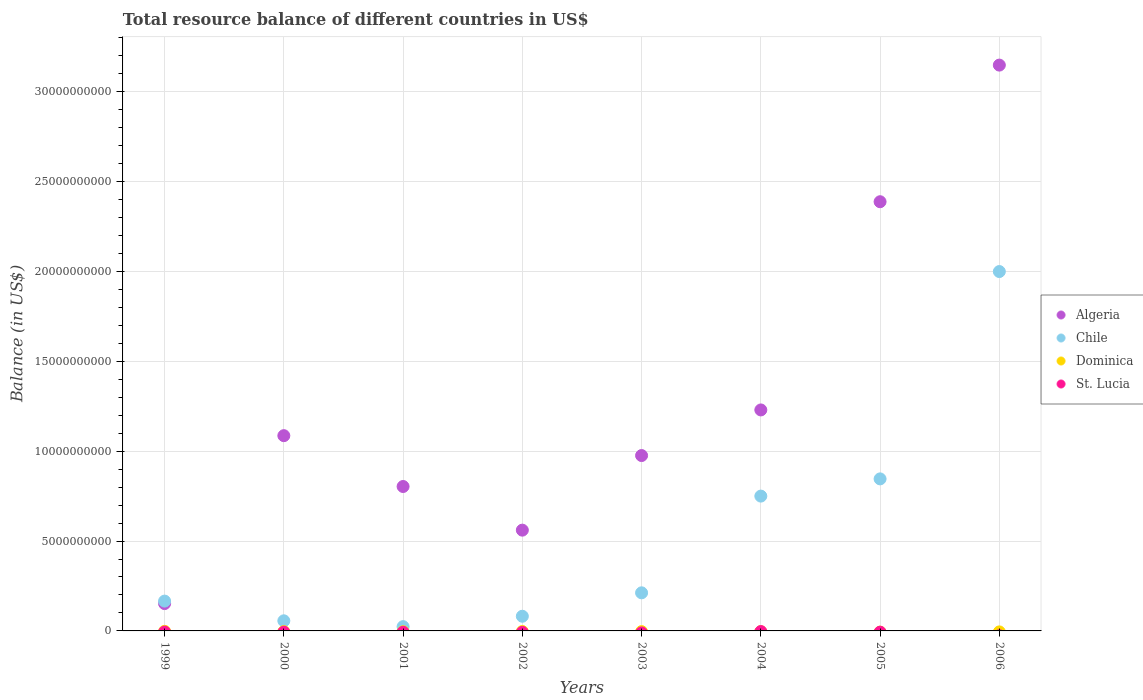What is the total resource balance in Algeria in 2003?
Provide a succinct answer. 9.75e+09. Across all years, what is the maximum total resource balance in Algeria?
Your answer should be compact. 3.15e+1. Across all years, what is the minimum total resource balance in Algeria?
Provide a succinct answer. 1.52e+09. In which year was the total resource balance in Chile maximum?
Make the answer very short. 2006. What is the total total resource balance in St. Lucia in the graph?
Ensure brevity in your answer.  0. What is the difference between the total resource balance in Algeria in 1999 and that in 2002?
Offer a very short reply. -4.09e+09. What is the difference between the total resource balance in Dominica in 2002 and the total resource balance in Algeria in 2003?
Ensure brevity in your answer.  -9.75e+09. What is the average total resource balance in Chile per year?
Ensure brevity in your answer.  5.17e+09. In the year 2006, what is the difference between the total resource balance in Chile and total resource balance in Algeria?
Your response must be concise. -1.15e+1. What is the ratio of the total resource balance in Chile in 1999 to that in 2001?
Offer a terse response. 6.95. What is the difference between the highest and the second highest total resource balance in Algeria?
Keep it short and to the point. 7.60e+09. What is the difference between the highest and the lowest total resource balance in Algeria?
Make the answer very short. 3.00e+1. In how many years, is the total resource balance in Dominica greater than the average total resource balance in Dominica taken over all years?
Your answer should be very brief. 0. Is the sum of the total resource balance in Chile in 2002 and 2006 greater than the maximum total resource balance in St. Lucia across all years?
Your answer should be compact. Yes. Is the total resource balance in St. Lucia strictly less than the total resource balance in Chile over the years?
Make the answer very short. Yes. How many years are there in the graph?
Provide a short and direct response. 8. Are the values on the major ticks of Y-axis written in scientific E-notation?
Keep it short and to the point. No. How many legend labels are there?
Make the answer very short. 4. What is the title of the graph?
Provide a succinct answer. Total resource balance of different countries in US$. What is the label or title of the Y-axis?
Ensure brevity in your answer.  Balance (in US$). What is the Balance (in US$) of Algeria in 1999?
Your answer should be very brief. 1.52e+09. What is the Balance (in US$) in Chile in 1999?
Provide a short and direct response. 1.66e+09. What is the Balance (in US$) in St. Lucia in 1999?
Make the answer very short. 0. What is the Balance (in US$) in Algeria in 2000?
Ensure brevity in your answer.  1.09e+1. What is the Balance (in US$) in Chile in 2000?
Offer a very short reply. 5.63e+08. What is the Balance (in US$) of Dominica in 2000?
Your answer should be compact. 0. What is the Balance (in US$) of St. Lucia in 2000?
Keep it short and to the point. 0. What is the Balance (in US$) of Algeria in 2001?
Offer a very short reply. 8.03e+09. What is the Balance (in US$) of Chile in 2001?
Offer a very short reply. 2.38e+08. What is the Balance (in US$) of Dominica in 2001?
Your answer should be very brief. 0. What is the Balance (in US$) in Algeria in 2002?
Keep it short and to the point. 5.61e+09. What is the Balance (in US$) of Chile in 2002?
Keep it short and to the point. 8.16e+08. What is the Balance (in US$) in Dominica in 2002?
Offer a terse response. 0. What is the Balance (in US$) in St. Lucia in 2002?
Make the answer very short. 0. What is the Balance (in US$) of Algeria in 2003?
Offer a very short reply. 9.75e+09. What is the Balance (in US$) of Chile in 2003?
Give a very brief answer. 2.12e+09. What is the Balance (in US$) in Algeria in 2004?
Offer a terse response. 1.23e+1. What is the Balance (in US$) of Chile in 2004?
Your response must be concise. 7.50e+09. What is the Balance (in US$) in St. Lucia in 2004?
Give a very brief answer. 0. What is the Balance (in US$) of Algeria in 2005?
Your answer should be very brief. 2.39e+1. What is the Balance (in US$) in Chile in 2005?
Offer a very short reply. 8.46e+09. What is the Balance (in US$) in Dominica in 2005?
Provide a succinct answer. 0. What is the Balance (in US$) of Algeria in 2006?
Your answer should be very brief. 3.15e+1. What is the Balance (in US$) of Chile in 2006?
Offer a terse response. 2.00e+1. What is the Balance (in US$) of St. Lucia in 2006?
Offer a very short reply. 0. Across all years, what is the maximum Balance (in US$) of Algeria?
Keep it short and to the point. 3.15e+1. Across all years, what is the maximum Balance (in US$) of Chile?
Keep it short and to the point. 2.00e+1. Across all years, what is the minimum Balance (in US$) in Algeria?
Offer a very short reply. 1.52e+09. Across all years, what is the minimum Balance (in US$) of Chile?
Make the answer very short. 2.38e+08. What is the total Balance (in US$) in Algeria in the graph?
Make the answer very short. 1.03e+11. What is the total Balance (in US$) of Chile in the graph?
Offer a very short reply. 4.13e+1. What is the difference between the Balance (in US$) in Algeria in 1999 and that in 2000?
Offer a terse response. -9.34e+09. What is the difference between the Balance (in US$) in Chile in 1999 and that in 2000?
Offer a very short reply. 1.10e+09. What is the difference between the Balance (in US$) of Algeria in 1999 and that in 2001?
Provide a short and direct response. -6.51e+09. What is the difference between the Balance (in US$) in Chile in 1999 and that in 2001?
Provide a succinct answer. 1.42e+09. What is the difference between the Balance (in US$) in Algeria in 1999 and that in 2002?
Give a very brief answer. -4.09e+09. What is the difference between the Balance (in US$) in Chile in 1999 and that in 2002?
Offer a very short reply. 8.43e+08. What is the difference between the Balance (in US$) of Algeria in 1999 and that in 2003?
Your answer should be compact. -8.23e+09. What is the difference between the Balance (in US$) in Chile in 1999 and that in 2003?
Ensure brevity in your answer.  -4.60e+08. What is the difference between the Balance (in US$) in Algeria in 1999 and that in 2004?
Keep it short and to the point. -1.08e+1. What is the difference between the Balance (in US$) of Chile in 1999 and that in 2004?
Your answer should be compact. -5.84e+09. What is the difference between the Balance (in US$) in Algeria in 1999 and that in 2005?
Keep it short and to the point. -2.24e+1. What is the difference between the Balance (in US$) in Chile in 1999 and that in 2005?
Ensure brevity in your answer.  -6.80e+09. What is the difference between the Balance (in US$) of Algeria in 1999 and that in 2006?
Offer a terse response. -3.00e+1. What is the difference between the Balance (in US$) in Chile in 1999 and that in 2006?
Provide a short and direct response. -1.83e+1. What is the difference between the Balance (in US$) in Algeria in 2000 and that in 2001?
Make the answer very short. 2.83e+09. What is the difference between the Balance (in US$) in Chile in 2000 and that in 2001?
Provide a short and direct response. 3.24e+08. What is the difference between the Balance (in US$) of Algeria in 2000 and that in 2002?
Give a very brief answer. 5.25e+09. What is the difference between the Balance (in US$) of Chile in 2000 and that in 2002?
Your answer should be very brief. -2.53e+08. What is the difference between the Balance (in US$) in Algeria in 2000 and that in 2003?
Provide a succinct answer. 1.11e+09. What is the difference between the Balance (in US$) in Chile in 2000 and that in 2003?
Your answer should be compact. -1.56e+09. What is the difference between the Balance (in US$) of Algeria in 2000 and that in 2004?
Your answer should be compact. -1.43e+09. What is the difference between the Balance (in US$) in Chile in 2000 and that in 2004?
Your answer should be compact. -6.94e+09. What is the difference between the Balance (in US$) in Algeria in 2000 and that in 2005?
Provide a succinct answer. -1.30e+1. What is the difference between the Balance (in US$) of Chile in 2000 and that in 2005?
Your response must be concise. -7.89e+09. What is the difference between the Balance (in US$) of Algeria in 2000 and that in 2006?
Your response must be concise. -2.06e+1. What is the difference between the Balance (in US$) of Chile in 2000 and that in 2006?
Make the answer very short. -1.94e+1. What is the difference between the Balance (in US$) in Algeria in 2001 and that in 2002?
Provide a short and direct response. 2.43e+09. What is the difference between the Balance (in US$) of Chile in 2001 and that in 2002?
Keep it short and to the point. -5.78e+08. What is the difference between the Balance (in US$) in Algeria in 2001 and that in 2003?
Provide a short and direct response. -1.72e+09. What is the difference between the Balance (in US$) in Chile in 2001 and that in 2003?
Ensure brevity in your answer.  -1.88e+09. What is the difference between the Balance (in US$) in Algeria in 2001 and that in 2004?
Your answer should be compact. -4.26e+09. What is the difference between the Balance (in US$) of Chile in 2001 and that in 2004?
Ensure brevity in your answer.  -7.26e+09. What is the difference between the Balance (in US$) in Algeria in 2001 and that in 2005?
Make the answer very short. -1.58e+1. What is the difference between the Balance (in US$) of Chile in 2001 and that in 2005?
Your answer should be compact. -8.22e+09. What is the difference between the Balance (in US$) in Algeria in 2001 and that in 2006?
Offer a terse response. -2.34e+1. What is the difference between the Balance (in US$) of Chile in 2001 and that in 2006?
Your answer should be very brief. -1.97e+1. What is the difference between the Balance (in US$) in Algeria in 2002 and that in 2003?
Ensure brevity in your answer.  -4.15e+09. What is the difference between the Balance (in US$) in Chile in 2002 and that in 2003?
Your answer should be very brief. -1.30e+09. What is the difference between the Balance (in US$) in Algeria in 2002 and that in 2004?
Your answer should be compact. -6.69e+09. What is the difference between the Balance (in US$) in Chile in 2002 and that in 2004?
Your answer should be compact. -6.68e+09. What is the difference between the Balance (in US$) of Algeria in 2002 and that in 2005?
Ensure brevity in your answer.  -1.83e+1. What is the difference between the Balance (in US$) in Chile in 2002 and that in 2005?
Ensure brevity in your answer.  -7.64e+09. What is the difference between the Balance (in US$) in Algeria in 2002 and that in 2006?
Offer a terse response. -2.59e+1. What is the difference between the Balance (in US$) in Chile in 2002 and that in 2006?
Make the answer very short. -1.92e+1. What is the difference between the Balance (in US$) of Algeria in 2003 and that in 2004?
Offer a terse response. -2.54e+09. What is the difference between the Balance (in US$) of Chile in 2003 and that in 2004?
Your answer should be compact. -5.38e+09. What is the difference between the Balance (in US$) of Algeria in 2003 and that in 2005?
Offer a terse response. -1.41e+1. What is the difference between the Balance (in US$) of Chile in 2003 and that in 2005?
Offer a terse response. -6.34e+09. What is the difference between the Balance (in US$) in Algeria in 2003 and that in 2006?
Make the answer very short. -2.17e+1. What is the difference between the Balance (in US$) of Chile in 2003 and that in 2006?
Provide a short and direct response. -1.79e+1. What is the difference between the Balance (in US$) in Algeria in 2004 and that in 2005?
Your response must be concise. -1.16e+1. What is the difference between the Balance (in US$) in Chile in 2004 and that in 2005?
Give a very brief answer. -9.58e+08. What is the difference between the Balance (in US$) in Algeria in 2004 and that in 2006?
Make the answer very short. -1.92e+1. What is the difference between the Balance (in US$) of Chile in 2004 and that in 2006?
Keep it short and to the point. -1.25e+1. What is the difference between the Balance (in US$) in Algeria in 2005 and that in 2006?
Your response must be concise. -7.60e+09. What is the difference between the Balance (in US$) of Chile in 2005 and that in 2006?
Provide a succinct answer. -1.15e+1. What is the difference between the Balance (in US$) in Algeria in 1999 and the Balance (in US$) in Chile in 2000?
Give a very brief answer. 9.57e+08. What is the difference between the Balance (in US$) in Algeria in 1999 and the Balance (in US$) in Chile in 2001?
Offer a very short reply. 1.28e+09. What is the difference between the Balance (in US$) of Algeria in 1999 and the Balance (in US$) of Chile in 2002?
Your answer should be very brief. 7.04e+08. What is the difference between the Balance (in US$) in Algeria in 1999 and the Balance (in US$) in Chile in 2003?
Give a very brief answer. -5.99e+08. What is the difference between the Balance (in US$) in Algeria in 1999 and the Balance (in US$) in Chile in 2004?
Your answer should be very brief. -5.98e+09. What is the difference between the Balance (in US$) of Algeria in 1999 and the Balance (in US$) of Chile in 2005?
Offer a very short reply. -6.94e+09. What is the difference between the Balance (in US$) in Algeria in 1999 and the Balance (in US$) in Chile in 2006?
Provide a short and direct response. -1.85e+1. What is the difference between the Balance (in US$) of Algeria in 2000 and the Balance (in US$) of Chile in 2001?
Make the answer very short. 1.06e+1. What is the difference between the Balance (in US$) in Algeria in 2000 and the Balance (in US$) in Chile in 2002?
Offer a very short reply. 1.00e+1. What is the difference between the Balance (in US$) in Algeria in 2000 and the Balance (in US$) in Chile in 2003?
Ensure brevity in your answer.  8.74e+09. What is the difference between the Balance (in US$) of Algeria in 2000 and the Balance (in US$) of Chile in 2004?
Make the answer very short. 3.36e+09. What is the difference between the Balance (in US$) in Algeria in 2000 and the Balance (in US$) in Chile in 2005?
Make the answer very short. 2.40e+09. What is the difference between the Balance (in US$) in Algeria in 2000 and the Balance (in US$) in Chile in 2006?
Keep it short and to the point. -9.13e+09. What is the difference between the Balance (in US$) of Algeria in 2001 and the Balance (in US$) of Chile in 2002?
Provide a short and direct response. 7.22e+09. What is the difference between the Balance (in US$) in Algeria in 2001 and the Balance (in US$) in Chile in 2003?
Provide a succinct answer. 5.91e+09. What is the difference between the Balance (in US$) in Algeria in 2001 and the Balance (in US$) in Chile in 2004?
Offer a very short reply. 5.34e+08. What is the difference between the Balance (in US$) in Algeria in 2001 and the Balance (in US$) in Chile in 2005?
Keep it short and to the point. -4.24e+08. What is the difference between the Balance (in US$) of Algeria in 2001 and the Balance (in US$) of Chile in 2006?
Provide a short and direct response. -1.20e+1. What is the difference between the Balance (in US$) of Algeria in 2002 and the Balance (in US$) of Chile in 2003?
Your answer should be very brief. 3.49e+09. What is the difference between the Balance (in US$) of Algeria in 2002 and the Balance (in US$) of Chile in 2004?
Your answer should be very brief. -1.89e+09. What is the difference between the Balance (in US$) in Algeria in 2002 and the Balance (in US$) in Chile in 2005?
Make the answer very short. -2.85e+09. What is the difference between the Balance (in US$) of Algeria in 2002 and the Balance (in US$) of Chile in 2006?
Your response must be concise. -1.44e+1. What is the difference between the Balance (in US$) of Algeria in 2003 and the Balance (in US$) of Chile in 2004?
Provide a succinct answer. 2.26e+09. What is the difference between the Balance (in US$) of Algeria in 2003 and the Balance (in US$) of Chile in 2005?
Ensure brevity in your answer.  1.30e+09. What is the difference between the Balance (in US$) in Algeria in 2003 and the Balance (in US$) in Chile in 2006?
Offer a terse response. -1.02e+1. What is the difference between the Balance (in US$) of Algeria in 2004 and the Balance (in US$) of Chile in 2005?
Provide a succinct answer. 3.83e+09. What is the difference between the Balance (in US$) of Algeria in 2004 and the Balance (in US$) of Chile in 2006?
Keep it short and to the point. -7.70e+09. What is the difference between the Balance (in US$) of Algeria in 2005 and the Balance (in US$) of Chile in 2006?
Provide a short and direct response. 3.88e+09. What is the average Balance (in US$) of Algeria per year?
Make the answer very short. 1.29e+1. What is the average Balance (in US$) of Chile per year?
Ensure brevity in your answer.  5.17e+09. What is the average Balance (in US$) of St. Lucia per year?
Provide a short and direct response. 0. In the year 1999, what is the difference between the Balance (in US$) in Algeria and Balance (in US$) in Chile?
Give a very brief answer. -1.39e+08. In the year 2000, what is the difference between the Balance (in US$) of Algeria and Balance (in US$) of Chile?
Your answer should be compact. 1.03e+1. In the year 2001, what is the difference between the Balance (in US$) of Algeria and Balance (in US$) of Chile?
Your answer should be compact. 7.79e+09. In the year 2002, what is the difference between the Balance (in US$) of Algeria and Balance (in US$) of Chile?
Your answer should be very brief. 4.79e+09. In the year 2003, what is the difference between the Balance (in US$) of Algeria and Balance (in US$) of Chile?
Offer a very short reply. 7.64e+09. In the year 2004, what is the difference between the Balance (in US$) in Algeria and Balance (in US$) in Chile?
Offer a very short reply. 4.79e+09. In the year 2005, what is the difference between the Balance (in US$) of Algeria and Balance (in US$) of Chile?
Ensure brevity in your answer.  1.54e+1. In the year 2006, what is the difference between the Balance (in US$) in Algeria and Balance (in US$) in Chile?
Offer a terse response. 1.15e+1. What is the ratio of the Balance (in US$) in Algeria in 1999 to that in 2000?
Make the answer very short. 0.14. What is the ratio of the Balance (in US$) of Chile in 1999 to that in 2000?
Your answer should be very brief. 2.95. What is the ratio of the Balance (in US$) of Algeria in 1999 to that in 2001?
Keep it short and to the point. 0.19. What is the ratio of the Balance (in US$) of Chile in 1999 to that in 2001?
Ensure brevity in your answer.  6.95. What is the ratio of the Balance (in US$) in Algeria in 1999 to that in 2002?
Your answer should be compact. 0.27. What is the ratio of the Balance (in US$) of Chile in 1999 to that in 2002?
Give a very brief answer. 2.03. What is the ratio of the Balance (in US$) of Algeria in 1999 to that in 2003?
Your response must be concise. 0.16. What is the ratio of the Balance (in US$) in Chile in 1999 to that in 2003?
Ensure brevity in your answer.  0.78. What is the ratio of the Balance (in US$) of Algeria in 1999 to that in 2004?
Provide a succinct answer. 0.12. What is the ratio of the Balance (in US$) in Chile in 1999 to that in 2004?
Keep it short and to the point. 0.22. What is the ratio of the Balance (in US$) in Algeria in 1999 to that in 2005?
Provide a short and direct response. 0.06. What is the ratio of the Balance (in US$) of Chile in 1999 to that in 2005?
Offer a terse response. 0.2. What is the ratio of the Balance (in US$) of Algeria in 1999 to that in 2006?
Ensure brevity in your answer.  0.05. What is the ratio of the Balance (in US$) in Chile in 1999 to that in 2006?
Offer a very short reply. 0.08. What is the ratio of the Balance (in US$) of Algeria in 2000 to that in 2001?
Keep it short and to the point. 1.35. What is the ratio of the Balance (in US$) of Chile in 2000 to that in 2001?
Ensure brevity in your answer.  2.36. What is the ratio of the Balance (in US$) in Algeria in 2000 to that in 2002?
Keep it short and to the point. 1.94. What is the ratio of the Balance (in US$) of Chile in 2000 to that in 2002?
Make the answer very short. 0.69. What is the ratio of the Balance (in US$) in Algeria in 2000 to that in 2003?
Give a very brief answer. 1.11. What is the ratio of the Balance (in US$) of Chile in 2000 to that in 2003?
Give a very brief answer. 0.27. What is the ratio of the Balance (in US$) in Algeria in 2000 to that in 2004?
Offer a terse response. 0.88. What is the ratio of the Balance (in US$) of Chile in 2000 to that in 2004?
Make the answer very short. 0.07. What is the ratio of the Balance (in US$) in Algeria in 2000 to that in 2005?
Your answer should be very brief. 0.45. What is the ratio of the Balance (in US$) of Chile in 2000 to that in 2005?
Your answer should be very brief. 0.07. What is the ratio of the Balance (in US$) of Algeria in 2000 to that in 2006?
Keep it short and to the point. 0.35. What is the ratio of the Balance (in US$) of Chile in 2000 to that in 2006?
Your response must be concise. 0.03. What is the ratio of the Balance (in US$) of Algeria in 2001 to that in 2002?
Offer a terse response. 1.43. What is the ratio of the Balance (in US$) of Chile in 2001 to that in 2002?
Keep it short and to the point. 0.29. What is the ratio of the Balance (in US$) of Algeria in 2001 to that in 2003?
Offer a very short reply. 0.82. What is the ratio of the Balance (in US$) in Chile in 2001 to that in 2003?
Give a very brief answer. 0.11. What is the ratio of the Balance (in US$) in Algeria in 2001 to that in 2004?
Ensure brevity in your answer.  0.65. What is the ratio of the Balance (in US$) of Chile in 2001 to that in 2004?
Ensure brevity in your answer.  0.03. What is the ratio of the Balance (in US$) of Algeria in 2001 to that in 2005?
Provide a short and direct response. 0.34. What is the ratio of the Balance (in US$) of Chile in 2001 to that in 2005?
Offer a terse response. 0.03. What is the ratio of the Balance (in US$) of Algeria in 2001 to that in 2006?
Provide a short and direct response. 0.26. What is the ratio of the Balance (in US$) of Chile in 2001 to that in 2006?
Offer a terse response. 0.01. What is the ratio of the Balance (in US$) of Algeria in 2002 to that in 2003?
Provide a short and direct response. 0.57. What is the ratio of the Balance (in US$) of Chile in 2002 to that in 2003?
Your response must be concise. 0.39. What is the ratio of the Balance (in US$) of Algeria in 2002 to that in 2004?
Provide a short and direct response. 0.46. What is the ratio of the Balance (in US$) in Chile in 2002 to that in 2004?
Your answer should be very brief. 0.11. What is the ratio of the Balance (in US$) in Algeria in 2002 to that in 2005?
Provide a short and direct response. 0.23. What is the ratio of the Balance (in US$) of Chile in 2002 to that in 2005?
Your answer should be compact. 0.1. What is the ratio of the Balance (in US$) of Algeria in 2002 to that in 2006?
Offer a very short reply. 0.18. What is the ratio of the Balance (in US$) of Chile in 2002 to that in 2006?
Your answer should be very brief. 0.04. What is the ratio of the Balance (in US$) of Algeria in 2003 to that in 2004?
Offer a terse response. 0.79. What is the ratio of the Balance (in US$) in Chile in 2003 to that in 2004?
Keep it short and to the point. 0.28. What is the ratio of the Balance (in US$) in Algeria in 2003 to that in 2005?
Make the answer very short. 0.41. What is the ratio of the Balance (in US$) in Chile in 2003 to that in 2005?
Provide a succinct answer. 0.25. What is the ratio of the Balance (in US$) in Algeria in 2003 to that in 2006?
Your response must be concise. 0.31. What is the ratio of the Balance (in US$) in Chile in 2003 to that in 2006?
Keep it short and to the point. 0.11. What is the ratio of the Balance (in US$) in Algeria in 2004 to that in 2005?
Your answer should be compact. 0.51. What is the ratio of the Balance (in US$) of Chile in 2004 to that in 2005?
Make the answer very short. 0.89. What is the ratio of the Balance (in US$) in Algeria in 2004 to that in 2006?
Give a very brief answer. 0.39. What is the ratio of the Balance (in US$) of Chile in 2004 to that in 2006?
Keep it short and to the point. 0.38. What is the ratio of the Balance (in US$) of Algeria in 2005 to that in 2006?
Give a very brief answer. 0.76. What is the ratio of the Balance (in US$) of Chile in 2005 to that in 2006?
Make the answer very short. 0.42. What is the difference between the highest and the second highest Balance (in US$) of Algeria?
Make the answer very short. 7.60e+09. What is the difference between the highest and the second highest Balance (in US$) of Chile?
Offer a terse response. 1.15e+1. What is the difference between the highest and the lowest Balance (in US$) of Algeria?
Your answer should be compact. 3.00e+1. What is the difference between the highest and the lowest Balance (in US$) of Chile?
Keep it short and to the point. 1.97e+1. 